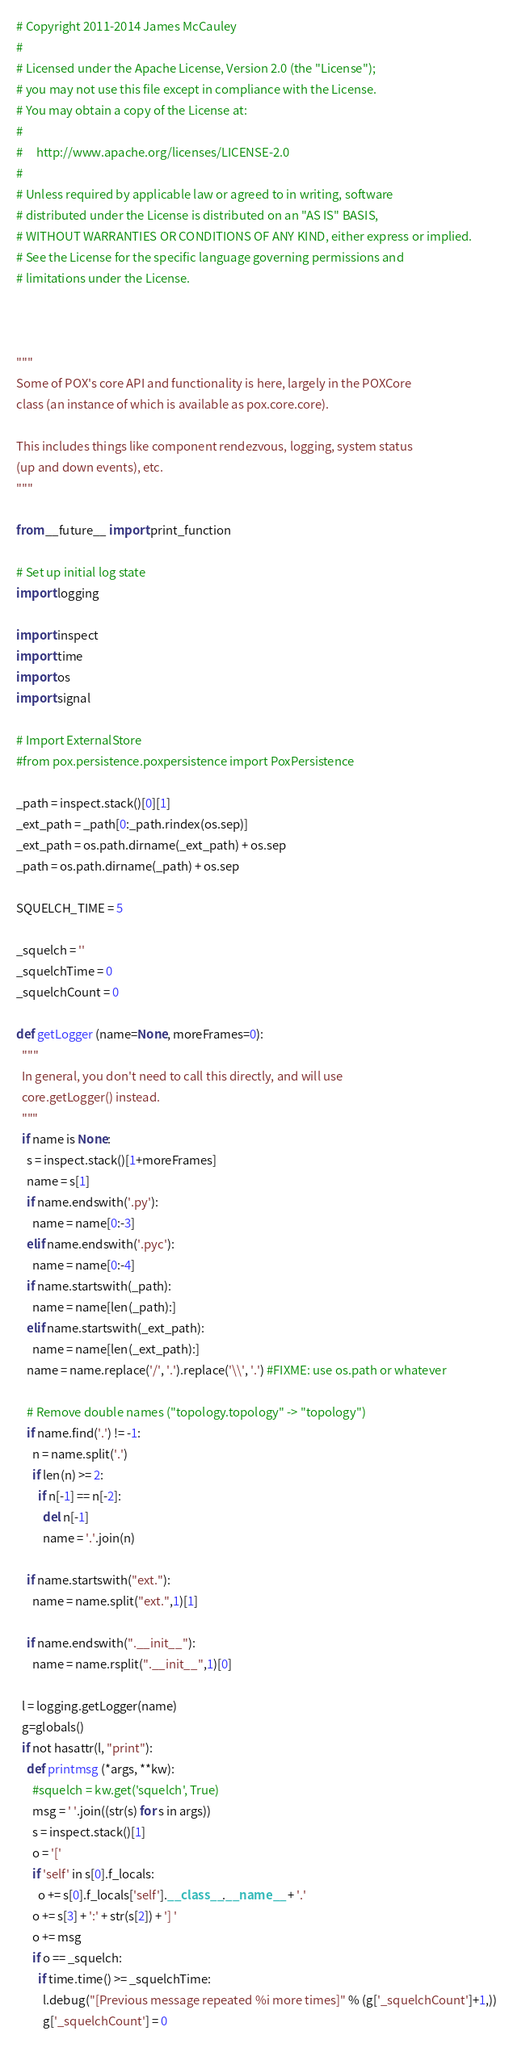<code> <loc_0><loc_0><loc_500><loc_500><_Python_># Copyright 2011-2014 James McCauley
#
# Licensed under the Apache License, Version 2.0 (the "License");
# you may not use this file except in compliance with the License.
# You may obtain a copy of the License at:
#
#     http://www.apache.org/licenses/LICENSE-2.0
#
# Unless required by applicable law or agreed to in writing, software
# distributed under the License is distributed on an "AS IS" BASIS,
# WITHOUT WARRANTIES OR CONDITIONS OF ANY KIND, either express or implied.
# See the License for the specific language governing permissions and
# limitations under the License.



"""
Some of POX's core API and functionality is here, largely in the POXCore
class (an instance of which is available as pox.core.core).

This includes things like component rendezvous, logging, system status
(up and down events), etc.
"""

from __future__ import print_function

# Set up initial log state
import logging

import inspect
import time
import os
import signal

# Import ExternalStore
#from pox.persistence.poxpersistence import PoxPersistence

_path = inspect.stack()[0][1]
_ext_path = _path[0:_path.rindex(os.sep)]
_ext_path = os.path.dirname(_ext_path) + os.sep
_path = os.path.dirname(_path) + os.sep

SQUELCH_TIME = 5

_squelch = ''
_squelchTime = 0
_squelchCount = 0

def getLogger (name=None, moreFrames=0):
  """
  In general, you don't need to call this directly, and will use
  core.getLogger() instead.
  """
  if name is None:
    s = inspect.stack()[1+moreFrames]
    name = s[1]
    if name.endswith('.py'):
      name = name[0:-3]
    elif name.endswith('.pyc'):
      name = name[0:-4]
    if name.startswith(_path):
      name = name[len(_path):]
    elif name.startswith(_ext_path):
      name = name[len(_ext_path):]
    name = name.replace('/', '.').replace('\\', '.') #FIXME: use os.path or whatever

    # Remove double names ("topology.topology" -> "topology")
    if name.find('.') != -1:
      n = name.split('.')
      if len(n) >= 2:
        if n[-1] == n[-2]:
          del n[-1]
          name = '.'.join(n)

    if name.startswith("ext."):
      name = name.split("ext.",1)[1]

    if name.endswith(".__init__"):
      name = name.rsplit(".__init__",1)[0]

  l = logging.getLogger(name)
  g=globals()
  if not hasattr(l, "print"):
    def printmsg (*args, **kw):
      #squelch = kw.get('squelch', True)
      msg = ' '.join((str(s) for s in args))
      s = inspect.stack()[1]
      o = '['
      if 'self' in s[0].f_locals:
        o += s[0].f_locals['self'].__class__.__name__ + '.'
      o += s[3] + ':' + str(s[2]) + '] '
      o += msg
      if o == _squelch:
        if time.time() >= _squelchTime:
          l.debug("[Previous message repeated %i more times]" % (g['_squelchCount']+1,))
          g['_squelchCount'] = 0</code> 